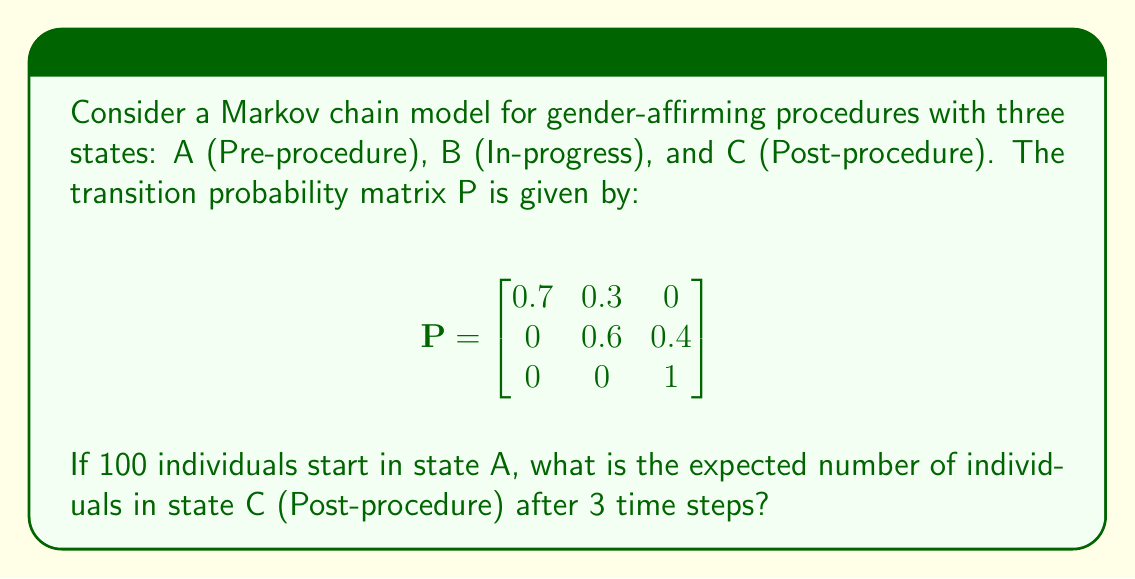Provide a solution to this math problem. To solve this problem, we need to calculate the state probability vector after 3 time steps and then determine the number of individuals in state C.

Step 1: Define the initial state vector.
$$\pi_0 = [100, 0, 0]$$

Step 2: Calculate the state vector after 3 time steps.
$$\pi_3 = \pi_0 \cdot P^3$$

To find $P^3$, we need to multiply P by itself three times:

$$P^2 = \begin{bmatrix}
0.49 & 0.39 & 0.12 \\
0 & 0.36 & 0.64 \\
0 & 0 & 1
\end{bmatrix}$$

$$P^3 = \begin{bmatrix}
0.343 & 0.3627 & 0.2943 \\
0 & 0.216 & 0.784 \\
0 & 0 & 1
\end{bmatrix}$$

Step 3: Multiply the initial state vector by $P^3$.
$$\pi_3 = [100, 0, 0] \cdot \begin{bmatrix}
0.343 & 0.3627 & 0.2943 \\
0 & 0.216 & 0.784 \\
0 & 0 & 1
\end{bmatrix}$$

$$\pi_3 = [34.3, 36.27, 29.43]$$

Step 4: The expected number of individuals in state C (Post-procedure) after 3 time steps is the third component of $\pi_3$.

Expected number in state C = 29.43
Answer: 29.43 